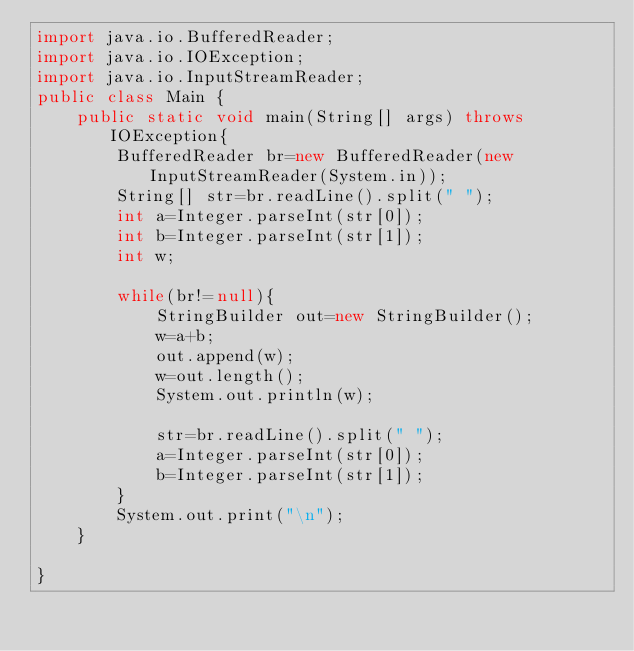<code> <loc_0><loc_0><loc_500><loc_500><_Java_>import java.io.BufferedReader;
import java.io.IOException;
import java.io.InputStreamReader;
public class Main {
	public static void main(String[] args) throws IOException{
		BufferedReader br=new BufferedReader(new InputStreamReader(System.in));
		String[] str=br.readLine().split(" ");
		int a=Integer.parseInt(str[0]);
		int b=Integer.parseInt(str[1]);
		int w;

		while(br!=null){
	        StringBuilder out=new StringBuilder();
			w=a+b;
			out.append(w);
			w=out.length();
			System.out.println(w);
		
			str=br.readLine().split(" ");
			a=Integer.parseInt(str[0]);
			b=Integer.parseInt(str[1]);
		}
		System.out.print("\n");
	}

}</code> 